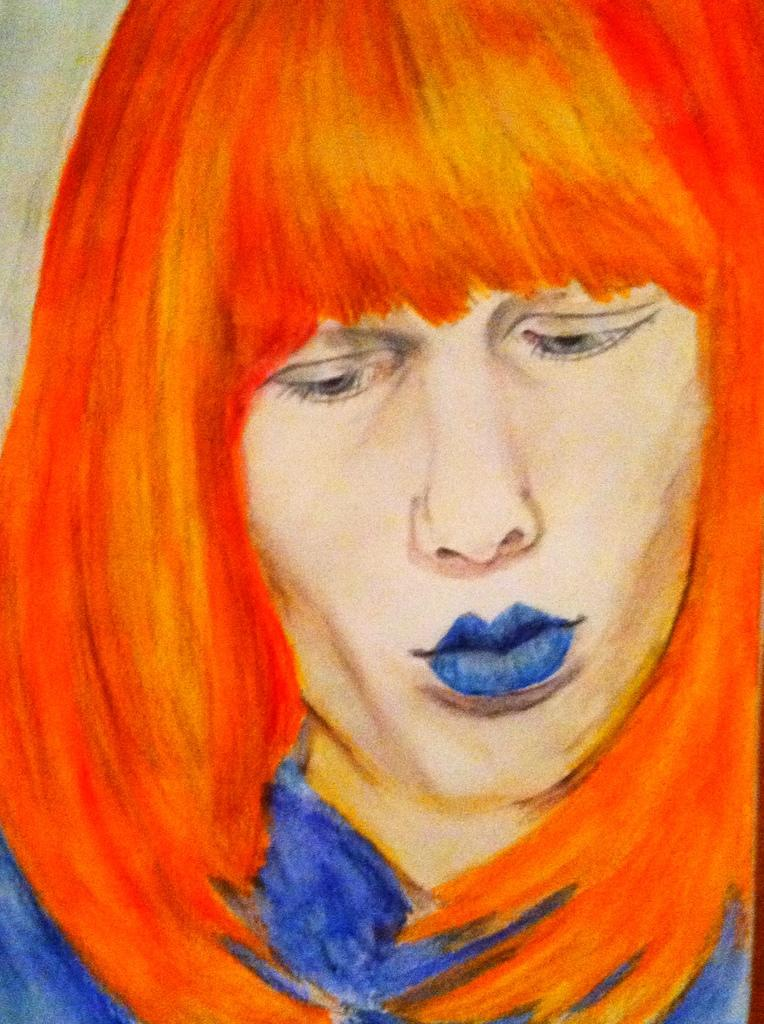What type of artwork is depicted in the image? The image is a painting. Can you describe the subject matter of the painting? There is a person in the painting. What type of destruction is being caused by the arm of the person in the painting? There is no indication of destruction or any specific action being performed by the person in the painting. 